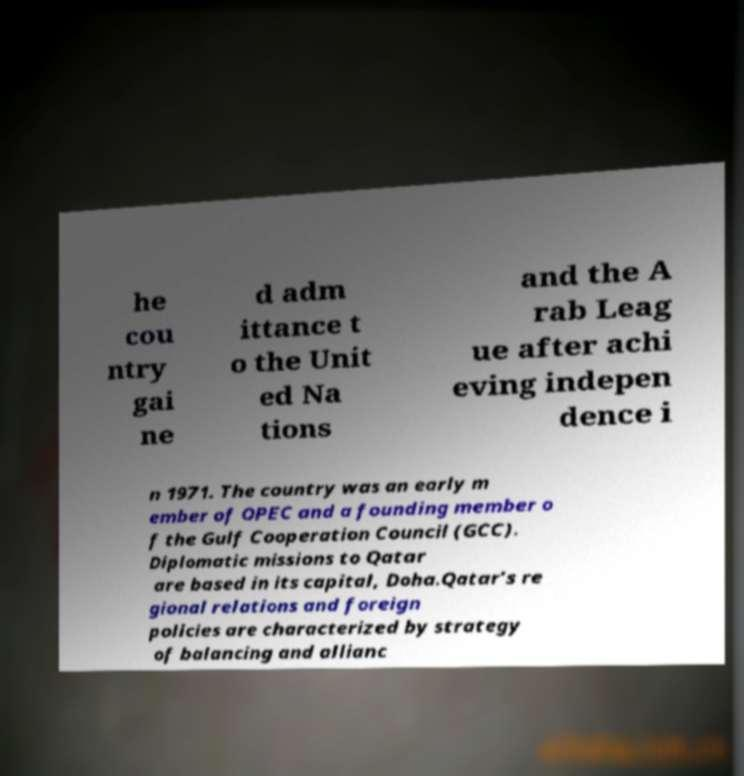There's text embedded in this image that I need extracted. Can you transcribe it verbatim? he cou ntry gai ne d adm ittance t o the Unit ed Na tions and the A rab Leag ue after achi eving indepen dence i n 1971. The country was an early m ember of OPEC and a founding member o f the Gulf Cooperation Council (GCC). Diplomatic missions to Qatar are based in its capital, Doha.Qatar’s re gional relations and foreign policies are characterized by strategy of balancing and allianc 